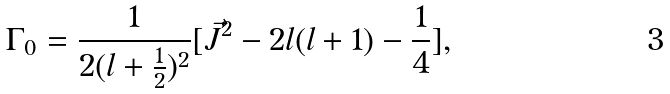Convert formula to latex. <formula><loc_0><loc_0><loc_500><loc_500>{ \Gamma } _ { 0 } = \frac { 1 } { 2 ( l + \frac { 1 } { 2 } ) ^ { 2 } } [ \vec { J } ^ { 2 } - 2 l ( l + 1 ) - \frac { 1 } { 4 } ] ,</formula> 